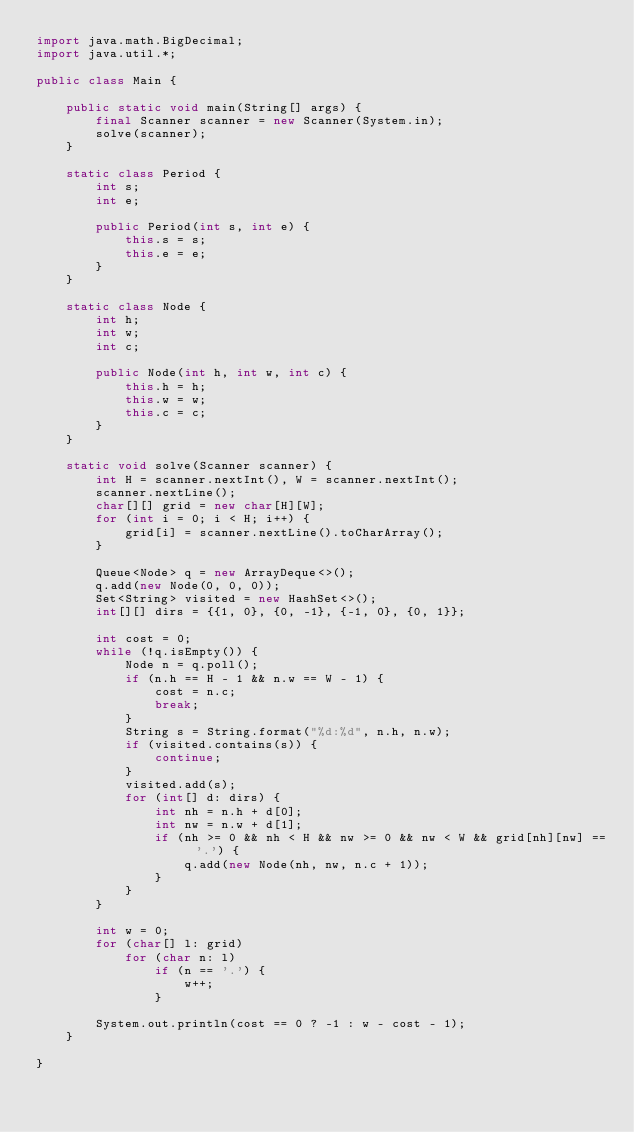<code> <loc_0><loc_0><loc_500><loc_500><_Java_>import java.math.BigDecimal;
import java.util.*;

public class Main {

    public static void main(String[] args) {
        final Scanner scanner = new Scanner(System.in);
        solve(scanner);
    }

    static class Period {
        int s;
        int e;

        public Period(int s, int e) {
            this.s = s;
            this.e = e;
        }
    }

    static class Node {
        int h;
        int w;
        int c;

        public Node(int h, int w, int c) {
            this.h = h;
            this.w = w;
            this.c = c;
        }
    }

    static void solve(Scanner scanner) {
        int H = scanner.nextInt(), W = scanner.nextInt();
        scanner.nextLine();
        char[][] grid = new char[H][W];
        for (int i = 0; i < H; i++) {
            grid[i] = scanner.nextLine().toCharArray();
        }

        Queue<Node> q = new ArrayDeque<>();
        q.add(new Node(0, 0, 0));
        Set<String> visited = new HashSet<>();
        int[][] dirs = {{1, 0}, {0, -1}, {-1, 0}, {0, 1}};

        int cost = 0;
        while (!q.isEmpty()) {
            Node n = q.poll();
            if (n.h == H - 1 && n.w == W - 1) {
                cost = n.c;
                break;
            }
            String s = String.format("%d:%d", n.h, n.w);
            if (visited.contains(s)) {
                continue;
            }
            visited.add(s);
            for (int[] d: dirs) {
                int nh = n.h + d[0];
                int nw = n.w + d[1];
                if (nh >= 0 && nh < H && nw >= 0 && nw < W && grid[nh][nw] == '.') {
                    q.add(new Node(nh, nw, n.c + 1));
                }
            }
        }

        int w = 0;
        for (char[] l: grid)
            for (char n: l)
                if (n == '.') {
                    w++;
                }

        System.out.println(cost == 0 ? -1 : w - cost - 1);
    }

}</code> 